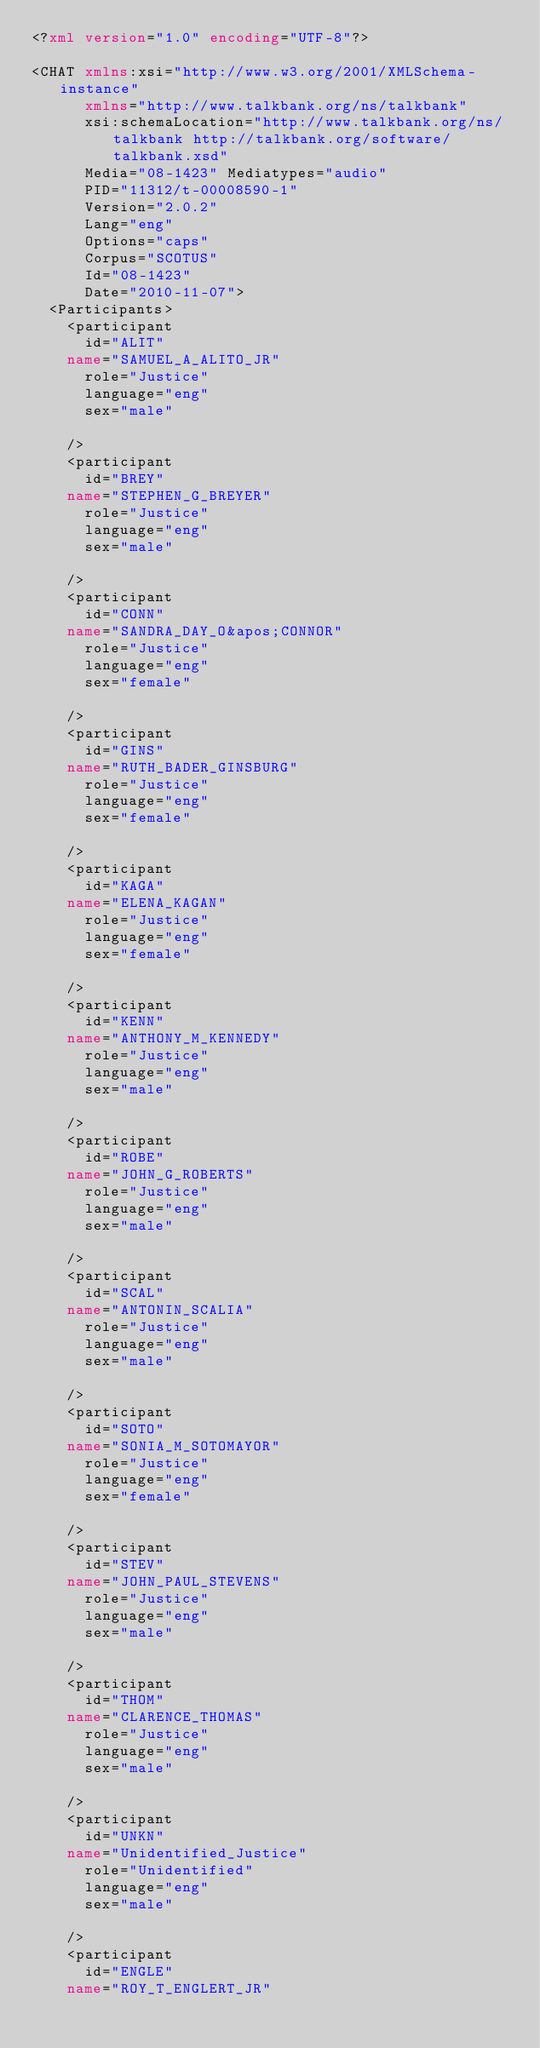<code> <loc_0><loc_0><loc_500><loc_500><_XML_><?xml version="1.0" encoding="UTF-8"?>

<CHAT xmlns:xsi="http://www.w3.org/2001/XMLSchema-instance"
      xmlns="http://www.talkbank.org/ns/talkbank"
      xsi:schemaLocation="http://www.talkbank.org/ns/talkbank http://talkbank.org/software/talkbank.xsd"
      Media="08-1423" Mediatypes="audio"
      PID="11312/t-00008590-1"
      Version="2.0.2"
      Lang="eng"
      Options="caps"
      Corpus="SCOTUS"
      Id="08-1423"
      Date="2010-11-07">
  <Participants>
    <participant
      id="ALIT"
    name="SAMUEL_A_ALITO_JR"
      role="Justice"
      language="eng"
      sex="male"

    />
    <participant
      id="BREY"
    name="STEPHEN_G_BREYER"
      role="Justice"
      language="eng"
      sex="male"

    />
    <participant
      id="CONN"
    name="SANDRA_DAY_O&apos;CONNOR"
      role="Justice"
      language="eng"
      sex="female"

    />
    <participant
      id="GINS"
    name="RUTH_BADER_GINSBURG"
      role="Justice"
      language="eng"
      sex="female"

    />
    <participant
      id="KAGA"
    name="ELENA_KAGAN"
      role="Justice"
      language="eng"
      sex="female"

    />
    <participant
      id="KENN"
    name="ANTHONY_M_KENNEDY"
      role="Justice"
      language="eng"
      sex="male"

    />
    <participant
      id="ROBE"
    name="JOHN_G_ROBERTS"
      role="Justice"
      language="eng"
      sex="male"

    />
    <participant
      id="SCAL"
    name="ANTONIN_SCALIA"
      role="Justice"
      language="eng"
      sex="male"

    />
    <participant
      id="SOTO"
    name="SONIA_M_SOTOMAYOR"
      role="Justice"
      language="eng"
      sex="female"

    />
    <participant
      id="STEV"
    name="JOHN_PAUL_STEVENS"
      role="Justice"
      language="eng"
      sex="male"

    />
    <participant
      id="THOM"
    name="CLARENCE_THOMAS"
      role="Justice"
      language="eng"
      sex="male"

    />
    <participant
      id="UNKN"
    name="Unidentified_Justice"
      role="Unidentified"
      language="eng"
      sex="male"

    />
    <participant
      id="ENGLE"
    name="ROY_T_ENGLERT_JR"</code> 